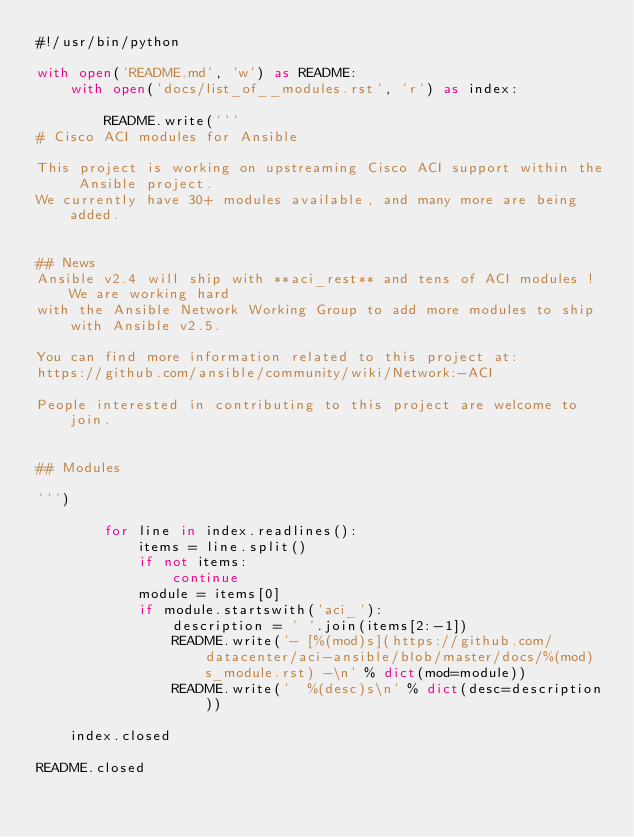<code> <loc_0><loc_0><loc_500><loc_500><_Python_>#!/usr/bin/python

with open('README.md', 'w') as README:
    with open('docs/list_of__modules.rst', 'r') as index:

        README.write('''
# Cisco ACI modules for Ansible

This project is working on upstreaming Cisco ACI support within the Ansible project.
We currently have 30+ modules available, and many more are being added.


## News
Ansible v2.4 will ship with **aci_rest** and tens of ACI modules ! We are working hard
with the Ansible Network Working Group to add more modules to ship with Ansible v2.5.

You can find more information related to this project at:
https://github.com/ansible/community/wiki/Network:-ACI

People interested in contributing to this project are welcome to join.


## Modules

''')

        for line in index.readlines():
            items = line.split()
            if not items:
                continue
            module = items[0]
            if module.startswith('aci_'):
                description = ' '.join(items[2:-1])
                README.write('- [%(mod)s](https://github.com/datacenter/aci-ansible/blob/master/docs/%(mod)s_module.rst) -\n' % dict(mod=module))
                README.write('  %(desc)s\n' % dict(desc=description))

    index.closed

README.closed
</code> 